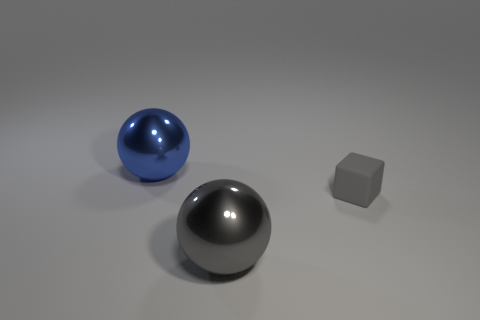Add 2 gray cubes. How many objects exist? 5 Subtract all blocks. How many objects are left? 2 Subtract 0 purple cylinders. How many objects are left? 3 Subtract all purple spheres. Subtract all blue cylinders. How many spheres are left? 2 Subtract all big gray metal spheres. Subtract all metal objects. How many objects are left? 0 Add 1 big blue balls. How many big blue balls are left? 2 Add 3 gray metal balls. How many gray metal balls exist? 4 